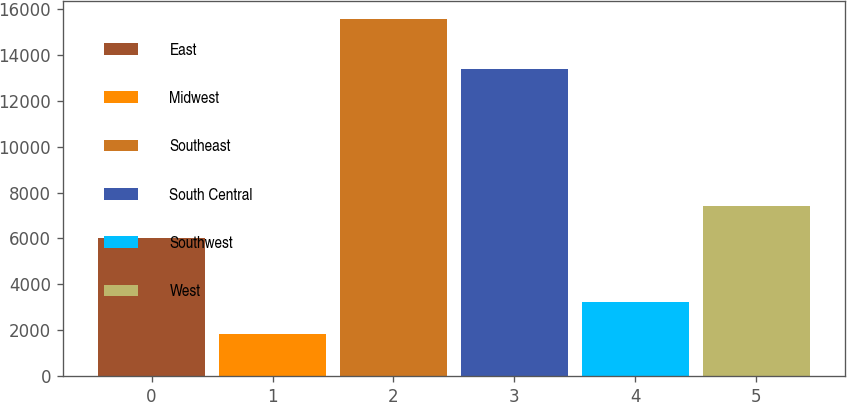<chart> <loc_0><loc_0><loc_500><loc_500><bar_chart><fcel>East<fcel>Midwest<fcel>Southeast<fcel>South Central<fcel>Southwest<fcel>West<nl><fcel>6039<fcel>1841<fcel>15575<fcel>13374<fcel>3214.4<fcel>7412.4<nl></chart> 